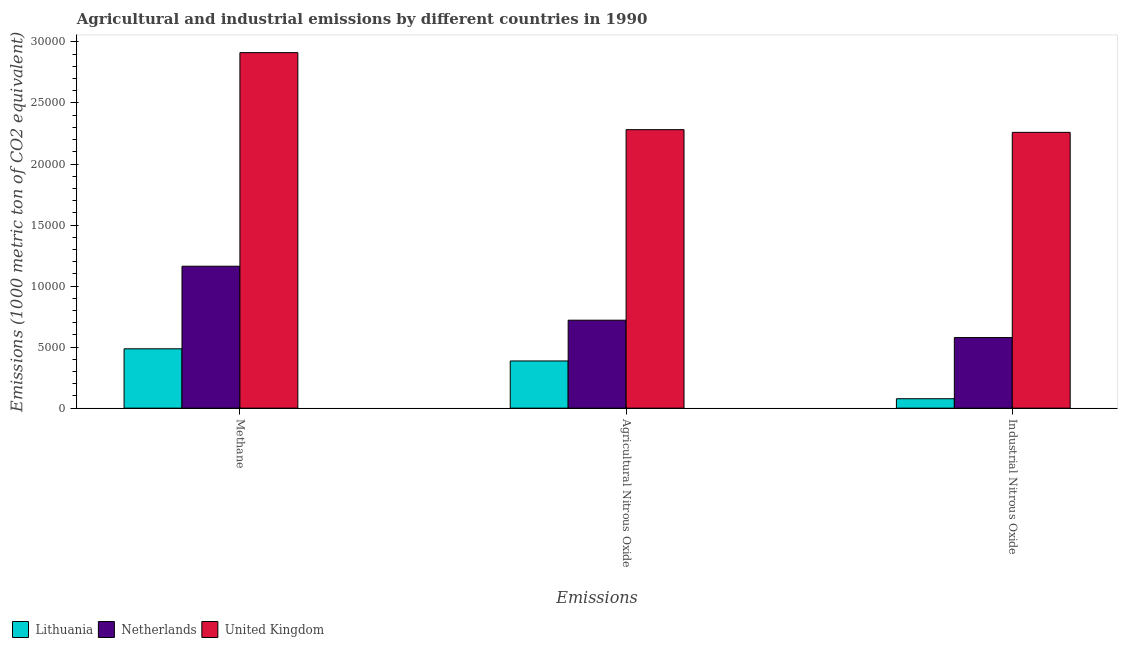How many different coloured bars are there?
Offer a very short reply. 3. How many groups of bars are there?
Your response must be concise. 3. Are the number of bars per tick equal to the number of legend labels?
Provide a short and direct response. Yes. How many bars are there on the 3rd tick from the right?
Your answer should be compact. 3. What is the label of the 2nd group of bars from the left?
Ensure brevity in your answer.  Agricultural Nitrous Oxide. What is the amount of agricultural nitrous oxide emissions in Lithuania?
Provide a succinct answer. 3865. Across all countries, what is the maximum amount of methane emissions?
Offer a very short reply. 2.91e+04. Across all countries, what is the minimum amount of agricultural nitrous oxide emissions?
Offer a terse response. 3865. In which country was the amount of methane emissions minimum?
Provide a succinct answer. Lithuania. What is the total amount of methane emissions in the graph?
Ensure brevity in your answer.  4.56e+04. What is the difference between the amount of industrial nitrous oxide emissions in Lithuania and that in United Kingdom?
Your answer should be compact. -2.18e+04. What is the difference between the amount of agricultural nitrous oxide emissions in Lithuania and the amount of methane emissions in United Kingdom?
Provide a succinct answer. -2.53e+04. What is the average amount of methane emissions per country?
Your answer should be compact. 1.52e+04. What is the difference between the amount of agricultural nitrous oxide emissions and amount of methane emissions in Netherlands?
Ensure brevity in your answer.  -4421. What is the ratio of the amount of agricultural nitrous oxide emissions in Netherlands to that in Lithuania?
Give a very brief answer. 1.86. Is the difference between the amount of methane emissions in Netherlands and United Kingdom greater than the difference between the amount of agricultural nitrous oxide emissions in Netherlands and United Kingdom?
Offer a terse response. No. What is the difference between the highest and the second highest amount of methane emissions?
Your answer should be compact. 1.75e+04. What is the difference between the highest and the lowest amount of agricultural nitrous oxide emissions?
Offer a terse response. 1.89e+04. Is the sum of the amount of industrial nitrous oxide emissions in United Kingdom and Netherlands greater than the maximum amount of methane emissions across all countries?
Provide a succinct answer. No. What does the 3rd bar from the left in Industrial Nitrous Oxide represents?
Provide a succinct answer. United Kingdom. What does the 3rd bar from the right in Agricultural Nitrous Oxide represents?
Give a very brief answer. Lithuania. How many bars are there?
Your answer should be compact. 9. Are all the bars in the graph horizontal?
Offer a very short reply. No. Are the values on the major ticks of Y-axis written in scientific E-notation?
Offer a terse response. No. Does the graph contain grids?
Provide a succinct answer. No. Where does the legend appear in the graph?
Your answer should be very brief. Bottom left. How are the legend labels stacked?
Keep it short and to the point. Horizontal. What is the title of the graph?
Give a very brief answer. Agricultural and industrial emissions by different countries in 1990. Does "Fiji" appear as one of the legend labels in the graph?
Your response must be concise. No. What is the label or title of the X-axis?
Your answer should be very brief. Emissions. What is the label or title of the Y-axis?
Keep it short and to the point. Emissions (1000 metric ton of CO2 equivalent). What is the Emissions (1000 metric ton of CO2 equivalent) in Lithuania in Methane?
Provide a succinct answer. 4861.3. What is the Emissions (1000 metric ton of CO2 equivalent) of Netherlands in Methane?
Give a very brief answer. 1.16e+04. What is the Emissions (1000 metric ton of CO2 equivalent) in United Kingdom in Methane?
Offer a terse response. 2.91e+04. What is the Emissions (1000 metric ton of CO2 equivalent) in Lithuania in Agricultural Nitrous Oxide?
Your answer should be very brief. 3865. What is the Emissions (1000 metric ton of CO2 equivalent) in Netherlands in Agricultural Nitrous Oxide?
Ensure brevity in your answer.  7205. What is the Emissions (1000 metric ton of CO2 equivalent) of United Kingdom in Agricultural Nitrous Oxide?
Ensure brevity in your answer.  2.28e+04. What is the Emissions (1000 metric ton of CO2 equivalent) of Lithuania in Industrial Nitrous Oxide?
Give a very brief answer. 771.2. What is the Emissions (1000 metric ton of CO2 equivalent) in Netherlands in Industrial Nitrous Oxide?
Provide a short and direct response. 5781.5. What is the Emissions (1000 metric ton of CO2 equivalent) in United Kingdom in Industrial Nitrous Oxide?
Make the answer very short. 2.26e+04. Across all Emissions, what is the maximum Emissions (1000 metric ton of CO2 equivalent) in Lithuania?
Your response must be concise. 4861.3. Across all Emissions, what is the maximum Emissions (1000 metric ton of CO2 equivalent) in Netherlands?
Make the answer very short. 1.16e+04. Across all Emissions, what is the maximum Emissions (1000 metric ton of CO2 equivalent) in United Kingdom?
Offer a terse response. 2.91e+04. Across all Emissions, what is the minimum Emissions (1000 metric ton of CO2 equivalent) in Lithuania?
Provide a short and direct response. 771.2. Across all Emissions, what is the minimum Emissions (1000 metric ton of CO2 equivalent) in Netherlands?
Your answer should be compact. 5781.5. Across all Emissions, what is the minimum Emissions (1000 metric ton of CO2 equivalent) of United Kingdom?
Keep it short and to the point. 2.26e+04. What is the total Emissions (1000 metric ton of CO2 equivalent) of Lithuania in the graph?
Your response must be concise. 9497.5. What is the total Emissions (1000 metric ton of CO2 equivalent) in Netherlands in the graph?
Offer a very short reply. 2.46e+04. What is the total Emissions (1000 metric ton of CO2 equivalent) of United Kingdom in the graph?
Ensure brevity in your answer.  7.45e+04. What is the difference between the Emissions (1000 metric ton of CO2 equivalent) in Lithuania in Methane and that in Agricultural Nitrous Oxide?
Your answer should be very brief. 996.3. What is the difference between the Emissions (1000 metric ton of CO2 equivalent) in Netherlands in Methane and that in Agricultural Nitrous Oxide?
Provide a short and direct response. 4421. What is the difference between the Emissions (1000 metric ton of CO2 equivalent) in United Kingdom in Methane and that in Agricultural Nitrous Oxide?
Keep it short and to the point. 6308.4. What is the difference between the Emissions (1000 metric ton of CO2 equivalent) of Lithuania in Methane and that in Industrial Nitrous Oxide?
Offer a very short reply. 4090.1. What is the difference between the Emissions (1000 metric ton of CO2 equivalent) of Netherlands in Methane and that in Industrial Nitrous Oxide?
Provide a short and direct response. 5844.5. What is the difference between the Emissions (1000 metric ton of CO2 equivalent) in United Kingdom in Methane and that in Industrial Nitrous Oxide?
Offer a very short reply. 6529.3. What is the difference between the Emissions (1000 metric ton of CO2 equivalent) in Lithuania in Agricultural Nitrous Oxide and that in Industrial Nitrous Oxide?
Ensure brevity in your answer.  3093.8. What is the difference between the Emissions (1000 metric ton of CO2 equivalent) of Netherlands in Agricultural Nitrous Oxide and that in Industrial Nitrous Oxide?
Your answer should be compact. 1423.5. What is the difference between the Emissions (1000 metric ton of CO2 equivalent) in United Kingdom in Agricultural Nitrous Oxide and that in Industrial Nitrous Oxide?
Keep it short and to the point. 220.9. What is the difference between the Emissions (1000 metric ton of CO2 equivalent) in Lithuania in Methane and the Emissions (1000 metric ton of CO2 equivalent) in Netherlands in Agricultural Nitrous Oxide?
Your answer should be very brief. -2343.7. What is the difference between the Emissions (1000 metric ton of CO2 equivalent) in Lithuania in Methane and the Emissions (1000 metric ton of CO2 equivalent) in United Kingdom in Agricultural Nitrous Oxide?
Make the answer very short. -1.80e+04. What is the difference between the Emissions (1000 metric ton of CO2 equivalent) in Netherlands in Methane and the Emissions (1000 metric ton of CO2 equivalent) in United Kingdom in Agricultural Nitrous Oxide?
Your answer should be very brief. -1.12e+04. What is the difference between the Emissions (1000 metric ton of CO2 equivalent) in Lithuania in Methane and the Emissions (1000 metric ton of CO2 equivalent) in Netherlands in Industrial Nitrous Oxide?
Provide a succinct answer. -920.2. What is the difference between the Emissions (1000 metric ton of CO2 equivalent) of Lithuania in Methane and the Emissions (1000 metric ton of CO2 equivalent) of United Kingdom in Industrial Nitrous Oxide?
Offer a very short reply. -1.77e+04. What is the difference between the Emissions (1000 metric ton of CO2 equivalent) in Netherlands in Methane and the Emissions (1000 metric ton of CO2 equivalent) in United Kingdom in Industrial Nitrous Oxide?
Keep it short and to the point. -1.10e+04. What is the difference between the Emissions (1000 metric ton of CO2 equivalent) of Lithuania in Agricultural Nitrous Oxide and the Emissions (1000 metric ton of CO2 equivalent) of Netherlands in Industrial Nitrous Oxide?
Offer a terse response. -1916.5. What is the difference between the Emissions (1000 metric ton of CO2 equivalent) in Lithuania in Agricultural Nitrous Oxide and the Emissions (1000 metric ton of CO2 equivalent) in United Kingdom in Industrial Nitrous Oxide?
Give a very brief answer. -1.87e+04. What is the difference between the Emissions (1000 metric ton of CO2 equivalent) in Netherlands in Agricultural Nitrous Oxide and the Emissions (1000 metric ton of CO2 equivalent) in United Kingdom in Industrial Nitrous Oxide?
Your answer should be compact. -1.54e+04. What is the average Emissions (1000 metric ton of CO2 equivalent) in Lithuania per Emissions?
Give a very brief answer. 3165.83. What is the average Emissions (1000 metric ton of CO2 equivalent) of Netherlands per Emissions?
Your answer should be very brief. 8204.17. What is the average Emissions (1000 metric ton of CO2 equivalent) of United Kingdom per Emissions?
Give a very brief answer. 2.48e+04. What is the difference between the Emissions (1000 metric ton of CO2 equivalent) of Lithuania and Emissions (1000 metric ton of CO2 equivalent) of Netherlands in Methane?
Your answer should be very brief. -6764.7. What is the difference between the Emissions (1000 metric ton of CO2 equivalent) in Lithuania and Emissions (1000 metric ton of CO2 equivalent) in United Kingdom in Methane?
Your response must be concise. -2.43e+04. What is the difference between the Emissions (1000 metric ton of CO2 equivalent) of Netherlands and Emissions (1000 metric ton of CO2 equivalent) of United Kingdom in Methane?
Provide a short and direct response. -1.75e+04. What is the difference between the Emissions (1000 metric ton of CO2 equivalent) of Lithuania and Emissions (1000 metric ton of CO2 equivalent) of Netherlands in Agricultural Nitrous Oxide?
Give a very brief answer. -3340. What is the difference between the Emissions (1000 metric ton of CO2 equivalent) in Lithuania and Emissions (1000 metric ton of CO2 equivalent) in United Kingdom in Agricultural Nitrous Oxide?
Offer a very short reply. -1.89e+04. What is the difference between the Emissions (1000 metric ton of CO2 equivalent) in Netherlands and Emissions (1000 metric ton of CO2 equivalent) in United Kingdom in Agricultural Nitrous Oxide?
Your answer should be compact. -1.56e+04. What is the difference between the Emissions (1000 metric ton of CO2 equivalent) of Lithuania and Emissions (1000 metric ton of CO2 equivalent) of Netherlands in Industrial Nitrous Oxide?
Keep it short and to the point. -5010.3. What is the difference between the Emissions (1000 metric ton of CO2 equivalent) in Lithuania and Emissions (1000 metric ton of CO2 equivalent) in United Kingdom in Industrial Nitrous Oxide?
Offer a very short reply. -2.18e+04. What is the difference between the Emissions (1000 metric ton of CO2 equivalent) in Netherlands and Emissions (1000 metric ton of CO2 equivalent) in United Kingdom in Industrial Nitrous Oxide?
Your answer should be compact. -1.68e+04. What is the ratio of the Emissions (1000 metric ton of CO2 equivalent) of Lithuania in Methane to that in Agricultural Nitrous Oxide?
Your answer should be very brief. 1.26. What is the ratio of the Emissions (1000 metric ton of CO2 equivalent) in Netherlands in Methane to that in Agricultural Nitrous Oxide?
Provide a short and direct response. 1.61. What is the ratio of the Emissions (1000 metric ton of CO2 equivalent) in United Kingdom in Methane to that in Agricultural Nitrous Oxide?
Your answer should be very brief. 1.28. What is the ratio of the Emissions (1000 metric ton of CO2 equivalent) in Lithuania in Methane to that in Industrial Nitrous Oxide?
Your response must be concise. 6.3. What is the ratio of the Emissions (1000 metric ton of CO2 equivalent) of Netherlands in Methane to that in Industrial Nitrous Oxide?
Your response must be concise. 2.01. What is the ratio of the Emissions (1000 metric ton of CO2 equivalent) of United Kingdom in Methane to that in Industrial Nitrous Oxide?
Offer a very short reply. 1.29. What is the ratio of the Emissions (1000 metric ton of CO2 equivalent) of Lithuania in Agricultural Nitrous Oxide to that in Industrial Nitrous Oxide?
Your answer should be compact. 5.01. What is the ratio of the Emissions (1000 metric ton of CO2 equivalent) in Netherlands in Agricultural Nitrous Oxide to that in Industrial Nitrous Oxide?
Your answer should be compact. 1.25. What is the ratio of the Emissions (1000 metric ton of CO2 equivalent) in United Kingdom in Agricultural Nitrous Oxide to that in Industrial Nitrous Oxide?
Your response must be concise. 1.01. What is the difference between the highest and the second highest Emissions (1000 metric ton of CO2 equivalent) of Lithuania?
Provide a short and direct response. 996.3. What is the difference between the highest and the second highest Emissions (1000 metric ton of CO2 equivalent) of Netherlands?
Your answer should be compact. 4421. What is the difference between the highest and the second highest Emissions (1000 metric ton of CO2 equivalent) of United Kingdom?
Make the answer very short. 6308.4. What is the difference between the highest and the lowest Emissions (1000 metric ton of CO2 equivalent) of Lithuania?
Provide a succinct answer. 4090.1. What is the difference between the highest and the lowest Emissions (1000 metric ton of CO2 equivalent) in Netherlands?
Your answer should be very brief. 5844.5. What is the difference between the highest and the lowest Emissions (1000 metric ton of CO2 equivalent) in United Kingdom?
Make the answer very short. 6529.3. 